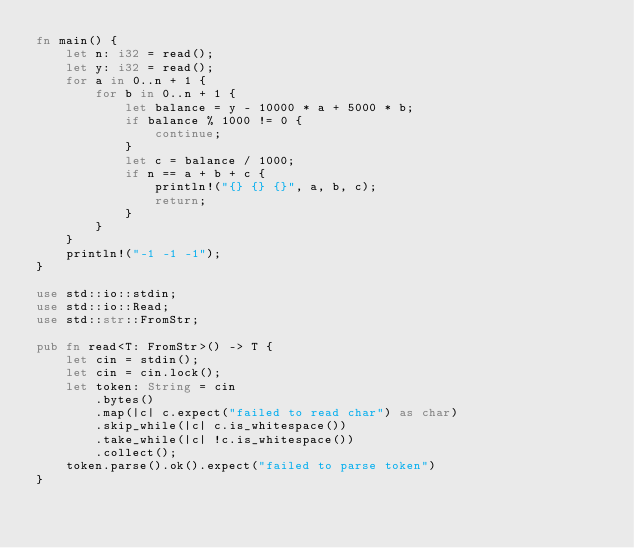<code> <loc_0><loc_0><loc_500><loc_500><_Rust_>fn main() {
    let n: i32 = read();
    let y: i32 = read();
    for a in 0..n + 1 {
        for b in 0..n + 1 {
            let balance = y - 10000 * a + 5000 * b;
            if balance % 1000 != 0 {
                continue;
            }
            let c = balance / 1000;
            if n == a + b + c {
                println!("{} {} {}", a, b, c);
                return;
            }
        }
    }
    println!("-1 -1 -1");
}

use std::io::stdin;
use std::io::Read;
use std::str::FromStr;

pub fn read<T: FromStr>() -> T {
    let cin = stdin();
    let cin = cin.lock();
    let token: String = cin
        .bytes()
        .map(|c| c.expect("failed to read char") as char)
        .skip_while(|c| c.is_whitespace())
        .take_while(|c| !c.is_whitespace())
        .collect();
    token.parse().ok().expect("failed to parse token")
}
</code> 